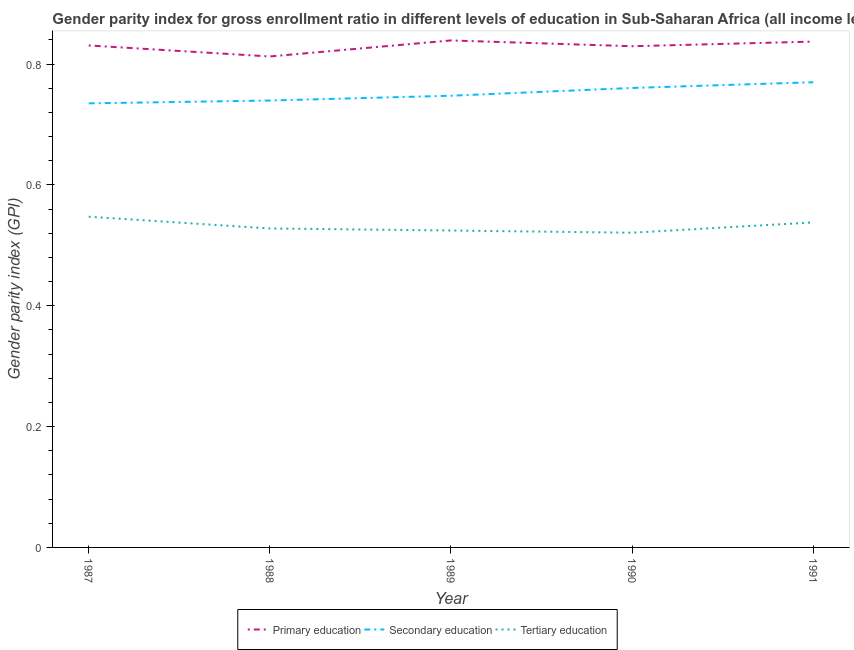What is the gender parity index in primary education in 1989?
Make the answer very short. 0.84. Across all years, what is the maximum gender parity index in secondary education?
Offer a very short reply. 0.77. Across all years, what is the minimum gender parity index in primary education?
Ensure brevity in your answer.  0.81. What is the total gender parity index in primary education in the graph?
Offer a very short reply. 4.15. What is the difference between the gender parity index in tertiary education in 1987 and that in 1989?
Offer a very short reply. 0.02. What is the difference between the gender parity index in primary education in 1990 and the gender parity index in secondary education in 1991?
Your answer should be very brief. 0.06. What is the average gender parity index in primary education per year?
Make the answer very short. 0.83. In the year 1987, what is the difference between the gender parity index in primary education and gender parity index in secondary education?
Offer a very short reply. 0.1. In how many years, is the gender parity index in primary education greater than 0.56?
Offer a very short reply. 5. What is the ratio of the gender parity index in tertiary education in 1987 to that in 1991?
Keep it short and to the point. 1.02. Is the gender parity index in tertiary education in 1987 less than that in 1988?
Give a very brief answer. No. What is the difference between the highest and the second highest gender parity index in primary education?
Make the answer very short. 0. What is the difference between the highest and the lowest gender parity index in primary education?
Provide a succinct answer. 0.03. In how many years, is the gender parity index in tertiary education greater than the average gender parity index in tertiary education taken over all years?
Provide a short and direct response. 2. Does the gender parity index in secondary education monotonically increase over the years?
Make the answer very short. Yes. Is the gender parity index in tertiary education strictly greater than the gender parity index in secondary education over the years?
Offer a terse response. No. How many lines are there?
Ensure brevity in your answer.  3. Are the values on the major ticks of Y-axis written in scientific E-notation?
Provide a short and direct response. No. Does the graph contain any zero values?
Give a very brief answer. No. Does the graph contain grids?
Offer a terse response. No. How many legend labels are there?
Provide a short and direct response. 3. What is the title of the graph?
Your answer should be very brief. Gender parity index for gross enrollment ratio in different levels of education in Sub-Saharan Africa (all income levels). Does "Refusal of sex" appear as one of the legend labels in the graph?
Your answer should be compact. No. What is the label or title of the X-axis?
Give a very brief answer. Year. What is the label or title of the Y-axis?
Give a very brief answer. Gender parity index (GPI). What is the Gender parity index (GPI) in Primary education in 1987?
Make the answer very short. 0.83. What is the Gender parity index (GPI) in Secondary education in 1987?
Give a very brief answer. 0.74. What is the Gender parity index (GPI) of Tertiary education in 1987?
Offer a very short reply. 0.55. What is the Gender parity index (GPI) of Primary education in 1988?
Your response must be concise. 0.81. What is the Gender parity index (GPI) in Secondary education in 1988?
Offer a terse response. 0.74. What is the Gender parity index (GPI) in Tertiary education in 1988?
Give a very brief answer. 0.53. What is the Gender parity index (GPI) of Primary education in 1989?
Offer a very short reply. 0.84. What is the Gender parity index (GPI) in Secondary education in 1989?
Make the answer very short. 0.75. What is the Gender parity index (GPI) in Tertiary education in 1989?
Ensure brevity in your answer.  0.52. What is the Gender parity index (GPI) of Primary education in 1990?
Your response must be concise. 0.83. What is the Gender parity index (GPI) in Secondary education in 1990?
Your answer should be very brief. 0.76. What is the Gender parity index (GPI) of Tertiary education in 1990?
Provide a short and direct response. 0.52. What is the Gender parity index (GPI) in Primary education in 1991?
Offer a terse response. 0.84. What is the Gender parity index (GPI) in Secondary education in 1991?
Give a very brief answer. 0.77. What is the Gender parity index (GPI) of Tertiary education in 1991?
Keep it short and to the point. 0.54. Across all years, what is the maximum Gender parity index (GPI) in Primary education?
Ensure brevity in your answer.  0.84. Across all years, what is the maximum Gender parity index (GPI) in Secondary education?
Give a very brief answer. 0.77. Across all years, what is the maximum Gender parity index (GPI) in Tertiary education?
Your answer should be very brief. 0.55. Across all years, what is the minimum Gender parity index (GPI) in Primary education?
Your answer should be very brief. 0.81. Across all years, what is the minimum Gender parity index (GPI) of Secondary education?
Your response must be concise. 0.74. Across all years, what is the minimum Gender parity index (GPI) in Tertiary education?
Your answer should be compact. 0.52. What is the total Gender parity index (GPI) in Primary education in the graph?
Provide a succinct answer. 4.15. What is the total Gender parity index (GPI) in Secondary education in the graph?
Your response must be concise. 3.75. What is the total Gender parity index (GPI) of Tertiary education in the graph?
Provide a succinct answer. 2.66. What is the difference between the Gender parity index (GPI) in Primary education in 1987 and that in 1988?
Your response must be concise. 0.02. What is the difference between the Gender parity index (GPI) in Secondary education in 1987 and that in 1988?
Provide a short and direct response. -0. What is the difference between the Gender parity index (GPI) in Tertiary education in 1987 and that in 1988?
Give a very brief answer. 0.02. What is the difference between the Gender parity index (GPI) of Primary education in 1987 and that in 1989?
Provide a succinct answer. -0.01. What is the difference between the Gender parity index (GPI) of Secondary education in 1987 and that in 1989?
Give a very brief answer. -0.01. What is the difference between the Gender parity index (GPI) in Tertiary education in 1987 and that in 1989?
Offer a very short reply. 0.02. What is the difference between the Gender parity index (GPI) in Primary education in 1987 and that in 1990?
Ensure brevity in your answer.  0. What is the difference between the Gender parity index (GPI) in Secondary education in 1987 and that in 1990?
Offer a terse response. -0.03. What is the difference between the Gender parity index (GPI) of Tertiary education in 1987 and that in 1990?
Offer a very short reply. 0.03. What is the difference between the Gender parity index (GPI) of Primary education in 1987 and that in 1991?
Your answer should be compact. -0.01. What is the difference between the Gender parity index (GPI) of Secondary education in 1987 and that in 1991?
Provide a short and direct response. -0.04. What is the difference between the Gender parity index (GPI) of Tertiary education in 1987 and that in 1991?
Make the answer very short. 0.01. What is the difference between the Gender parity index (GPI) in Primary education in 1988 and that in 1989?
Offer a terse response. -0.03. What is the difference between the Gender parity index (GPI) of Secondary education in 1988 and that in 1989?
Make the answer very short. -0.01. What is the difference between the Gender parity index (GPI) in Tertiary education in 1988 and that in 1989?
Provide a short and direct response. 0. What is the difference between the Gender parity index (GPI) of Primary education in 1988 and that in 1990?
Your answer should be very brief. -0.02. What is the difference between the Gender parity index (GPI) of Secondary education in 1988 and that in 1990?
Give a very brief answer. -0.02. What is the difference between the Gender parity index (GPI) in Tertiary education in 1988 and that in 1990?
Offer a terse response. 0.01. What is the difference between the Gender parity index (GPI) in Primary education in 1988 and that in 1991?
Offer a terse response. -0.02. What is the difference between the Gender parity index (GPI) in Secondary education in 1988 and that in 1991?
Make the answer very short. -0.03. What is the difference between the Gender parity index (GPI) of Tertiary education in 1988 and that in 1991?
Provide a short and direct response. -0.01. What is the difference between the Gender parity index (GPI) of Primary education in 1989 and that in 1990?
Your answer should be compact. 0.01. What is the difference between the Gender parity index (GPI) of Secondary education in 1989 and that in 1990?
Give a very brief answer. -0.01. What is the difference between the Gender parity index (GPI) of Tertiary education in 1989 and that in 1990?
Your answer should be compact. 0. What is the difference between the Gender parity index (GPI) in Primary education in 1989 and that in 1991?
Make the answer very short. 0. What is the difference between the Gender parity index (GPI) in Secondary education in 1989 and that in 1991?
Give a very brief answer. -0.02. What is the difference between the Gender parity index (GPI) in Tertiary education in 1989 and that in 1991?
Keep it short and to the point. -0.01. What is the difference between the Gender parity index (GPI) of Primary education in 1990 and that in 1991?
Your answer should be very brief. -0.01. What is the difference between the Gender parity index (GPI) of Secondary education in 1990 and that in 1991?
Provide a short and direct response. -0.01. What is the difference between the Gender parity index (GPI) of Tertiary education in 1990 and that in 1991?
Your answer should be compact. -0.02. What is the difference between the Gender parity index (GPI) in Primary education in 1987 and the Gender parity index (GPI) in Secondary education in 1988?
Provide a succinct answer. 0.09. What is the difference between the Gender parity index (GPI) of Primary education in 1987 and the Gender parity index (GPI) of Tertiary education in 1988?
Offer a very short reply. 0.3. What is the difference between the Gender parity index (GPI) of Secondary education in 1987 and the Gender parity index (GPI) of Tertiary education in 1988?
Offer a very short reply. 0.21. What is the difference between the Gender parity index (GPI) of Primary education in 1987 and the Gender parity index (GPI) of Secondary education in 1989?
Your answer should be compact. 0.08. What is the difference between the Gender parity index (GPI) of Primary education in 1987 and the Gender parity index (GPI) of Tertiary education in 1989?
Offer a terse response. 0.31. What is the difference between the Gender parity index (GPI) of Secondary education in 1987 and the Gender parity index (GPI) of Tertiary education in 1989?
Offer a very short reply. 0.21. What is the difference between the Gender parity index (GPI) of Primary education in 1987 and the Gender parity index (GPI) of Secondary education in 1990?
Keep it short and to the point. 0.07. What is the difference between the Gender parity index (GPI) of Primary education in 1987 and the Gender parity index (GPI) of Tertiary education in 1990?
Your response must be concise. 0.31. What is the difference between the Gender parity index (GPI) of Secondary education in 1987 and the Gender parity index (GPI) of Tertiary education in 1990?
Give a very brief answer. 0.21. What is the difference between the Gender parity index (GPI) in Primary education in 1987 and the Gender parity index (GPI) in Secondary education in 1991?
Make the answer very short. 0.06. What is the difference between the Gender parity index (GPI) in Primary education in 1987 and the Gender parity index (GPI) in Tertiary education in 1991?
Offer a very short reply. 0.29. What is the difference between the Gender parity index (GPI) in Secondary education in 1987 and the Gender parity index (GPI) in Tertiary education in 1991?
Keep it short and to the point. 0.2. What is the difference between the Gender parity index (GPI) of Primary education in 1988 and the Gender parity index (GPI) of Secondary education in 1989?
Your answer should be very brief. 0.07. What is the difference between the Gender parity index (GPI) of Primary education in 1988 and the Gender parity index (GPI) of Tertiary education in 1989?
Your response must be concise. 0.29. What is the difference between the Gender parity index (GPI) in Secondary education in 1988 and the Gender parity index (GPI) in Tertiary education in 1989?
Make the answer very short. 0.22. What is the difference between the Gender parity index (GPI) of Primary education in 1988 and the Gender parity index (GPI) of Secondary education in 1990?
Ensure brevity in your answer.  0.05. What is the difference between the Gender parity index (GPI) of Primary education in 1988 and the Gender parity index (GPI) of Tertiary education in 1990?
Provide a short and direct response. 0.29. What is the difference between the Gender parity index (GPI) in Secondary education in 1988 and the Gender parity index (GPI) in Tertiary education in 1990?
Your answer should be very brief. 0.22. What is the difference between the Gender parity index (GPI) of Primary education in 1988 and the Gender parity index (GPI) of Secondary education in 1991?
Your answer should be compact. 0.04. What is the difference between the Gender parity index (GPI) of Primary education in 1988 and the Gender parity index (GPI) of Tertiary education in 1991?
Offer a very short reply. 0.27. What is the difference between the Gender parity index (GPI) in Secondary education in 1988 and the Gender parity index (GPI) in Tertiary education in 1991?
Give a very brief answer. 0.2. What is the difference between the Gender parity index (GPI) in Primary education in 1989 and the Gender parity index (GPI) in Secondary education in 1990?
Provide a short and direct response. 0.08. What is the difference between the Gender parity index (GPI) in Primary education in 1989 and the Gender parity index (GPI) in Tertiary education in 1990?
Provide a succinct answer. 0.32. What is the difference between the Gender parity index (GPI) of Secondary education in 1989 and the Gender parity index (GPI) of Tertiary education in 1990?
Your answer should be very brief. 0.23. What is the difference between the Gender parity index (GPI) in Primary education in 1989 and the Gender parity index (GPI) in Secondary education in 1991?
Your response must be concise. 0.07. What is the difference between the Gender parity index (GPI) of Primary education in 1989 and the Gender parity index (GPI) of Tertiary education in 1991?
Give a very brief answer. 0.3. What is the difference between the Gender parity index (GPI) of Secondary education in 1989 and the Gender parity index (GPI) of Tertiary education in 1991?
Provide a short and direct response. 0.21. What is the difference between the Gender parity index (GPI) of Primary education in 1990 and the Gender parity index (GPI) of Secondary education in 1991?
Give a very brief answer. 0.06. What is the difference between the Gender parity index (GPI) in Primary education in 1990 and the Gender parity index (GPI) in Tertiary education in 1991?
Provide a short and direct response. 0.29. What is the difference between the Gender parity index (GPI) in Secondary education in 1990 and the Gender parity index (GPI) in Tertiary education in 1991?
Ensure brevity in your answer.  0.22. What is the average Gender parity index (GPI) in Primary education per year?
Provide a succinct answer. 0.83. What is the average Gender parity index (GPI) of Secondary education per year?
Your answer should be compact. 0.75. What is the average Gender parity index (GPI) of Tertiary education per year?
Your answer should be compact. 0.53. In the year 1987, what is the difference between the Gender parity index (GPI) of Primary education and Gender parity index (GPI) of Secondary education?
Your answer should be compact. 0.1. In the year 1987, what is the difference between the Gender parity index (GPI) of Primary education and Gender parity index (GPI) of Tertiary education?
Your answer should be very brief. 0.28. In the year 1987, what is the difference between the Gender parity index (GPI) in Secondary education and Gender parity index (GPI) in Tertiary education?
Provide a succinct answer. 0.19. In the year 1988, what is the difference between the Gender parity index (GPI) in Primary education and Gender parity index (GPI) in Secondary education?
Provide a succinct answer. 0.07. In the year 1988, what is the difference between the Gender parity index (GPI) in Primary education and Gender parity index (GPI) in Tertiary education?
Give a very brief answer. 0.28. In the year 1988, what is the difference between the Gender parity index (GPI) of Secondary education and Gender parity index (GPI) of Tertiary education?
Your response must be concise. 0.21. In the year 1989, what is the difference between the Gender parity index (GPI) of Primary education and Gender parity index (GPI) of Secondary education?
Your response must be concise. 0.09. In the year 1989, what is the difference between the Gender parity index (GPI) in Primary education and Gender parity index (GPI) in Tertiary education?
Your response must be concise. 0.31. In the year 1989, what is the difference between the Gender parity index (GPI) in Secondary education and Gender parity index (GPI) in Tertiary education?
Offer a terse response. 0.22. In the year 1990, what is the difference between the Gender parity index (GPI) in Primary education and Gender parity index (GPI) in Secondary education?
Give a very brief answer. 0.07. In the year 1990, what is the difference between the Gender parity index (GPI) in Primary education and Gender parity index (GPI) in Tertiary education?
Your answer should be very brief. 0.31. In the year 1990, what is the difference between the Gender parity index (GPI) of Secondary education and Gender parity index (GPI) of Tertiary education?
Keep it short and to the point. 0.24. In the year 1991, what is the difference between the Gender parity index (GPI) in Primary education and Gender parity index (GPI) in Secondary education?
Your answer should be compact. 0.07. In the year 1991, what is the difference between the Gender parity index (GPI) of Primary education and Gender parity index (GPI) of Tertiary education?
Provide a short and direct response. 0.3. In the year 1991, what is the difference between the Gender parity index (GPI) in Secondary education and Gender parity index (GPI) in Tertiary education?
Your answer should be very brief. 0.23. What is the ratio of the Gender parity index (GPI) of Primary education in 1987 to that in 1988?
Your answer should be very brief. 1.02. What is the ratio of the Gender parity index (GPI) of Tertiary education in 1987 to that in 1988?
Provide a short and direct response. 1.04. What is the ratio of the Gender parity index (GPI) in Primary education in 1987 to that in 1989?
Your answer should be very brief. 0.99. What is the ratio of the Gender parity index (GPI) in Secondary education in 1987 to that in 1989?
Ensure brevity in your answer.  0.98. What is the ratio of the Gender parity index (GPI) of Tertiary education in 1987 to that in 1989?
Ensure brevity in your answer.  1.04. What is the ratio of the Gender parity index (GPI) of Secondary education in 1987 to that in 1990?
Make the answer very short. 0.97. What is the ratio of the Gender parity index (GPI) of Tertiary education in 1987 to that in 1990?
Ensure brevity in your answer.  1.05. What is the ratio of the Gender parity index (GPI) in Primary education in 1987 to that in 1991?
Keep it short and to the point. 0.99. What is the ratio of the Gender parity index (GPI) of Secondary education in 1987 to that in 1991?
Keep it short and to the point. 0.95. What is the ratio of the Gender parity index (GPI) in Tertiary education in 1987 to that in 1991?
Offer a very short reply. 1.02. What is the ratio of the Gender parity index (GPI) in Primary education in 1988 to that in 1989?
Your answer should be compact. 0.97. What is the ratio of the Gender parity index (GPI) in Secondary education in 1988 to that in 1989?
Ensure brevity in your answer.  0.99. What is the ratio of the Gender parity index (GPI) in Tertiary education in 1988 to that in 1989?
Make the answer very short. 1.01. What is the ratio of the Gender parity index (GPI) in Primary education in 1988 to that in 1990?
Offer a terse response. 0.98. What is the ratio of the Gender parity index (GPI) of Secondary education in 1988 to that in 1990?
Give a very brief answer. 0.97. What is the ratio of the Gender parity index (GPI) of Tertiary education in 1988 to that in 1990?
Keep it short and to the point. 1.01. What is the ratio of the Gender parity index (GPI) in Primary education in 1988 to that in 1991?
Your response must be concise. 0.97. What is the ratio of the Gender parity index (GPI) in Secondary education in 1988 to that in 1991?
Offer a terse response. 0.96. What is the ratio of the Gender parity index (GPI) of Tertiary education in 1988 to that in 1991?
Give a very brief answer. 0.98. What is the ratio of the Gender parity index (GPI) in Primary education in 1989 to that in 1990?
Offer a terse response. 1.01. What is the ratio of the Gender parity index (GPI) in Secondary education in 1989 to that in 1990?
Your answer should be compact. 0.98. What is the ratio of the Gender parity index (GPI) in Tertiary education in 1989 to that in 1990?
Your answer should be very brief. 1.01. What is the ratio of the Gender parity index (GPI) of Primary education in 1989 to that in 1991?
Ensure brevity in your answer.  1. What is the ratio of the Gender parity index (GPI) of Secondary education in 1989 to that in 1991?
Give a very brief answer. 0.97. What is the ratio of the Gender parity index (GPI) of Tertiary education in 1989 to that in 1991?
Ensure brevity in your answer.  0.98. What is the ratio of the Gender parity index (GPI) of Primary education in 1990 to that in 1991?
Offer a very short reply. 0.99. What is the ratio of the Gender parity index (GPI) of Secondary education in 1990 to that in 1991?
Ensure brevity in your answer.  0.99. What is the ratio of the Gender parity index (GPI) of Tertiary education in 1990 to that in 1991?
Provide a short and direct response. 0.97. What is the difference between the highest and the second highest Gender parity index (GPI) in Primary education?
Offer a terse response. 0. What is the difference between the highest and the second highest Gender parity index (GPI) in Secondary education?
Keep it short and to the point. 0.01. What is the difference between the highest and the second highest Gender parity index (GPI) in Tertiary education?
Your answer should be very brief. 0.01. What is the difference between the highest and the lowest Gender parity index (GPI) in Primary education?
Offer a very short reply. 0.03. What is the difference between the highest and the lowest Gender parity index (GPI) in Secondary education?
Make the answer very short. 0.04. What is the difference between the highest and the lowest Gender parity index (GPI) of Tertiary education?
Ensure brevity in your answer.  0.03. 